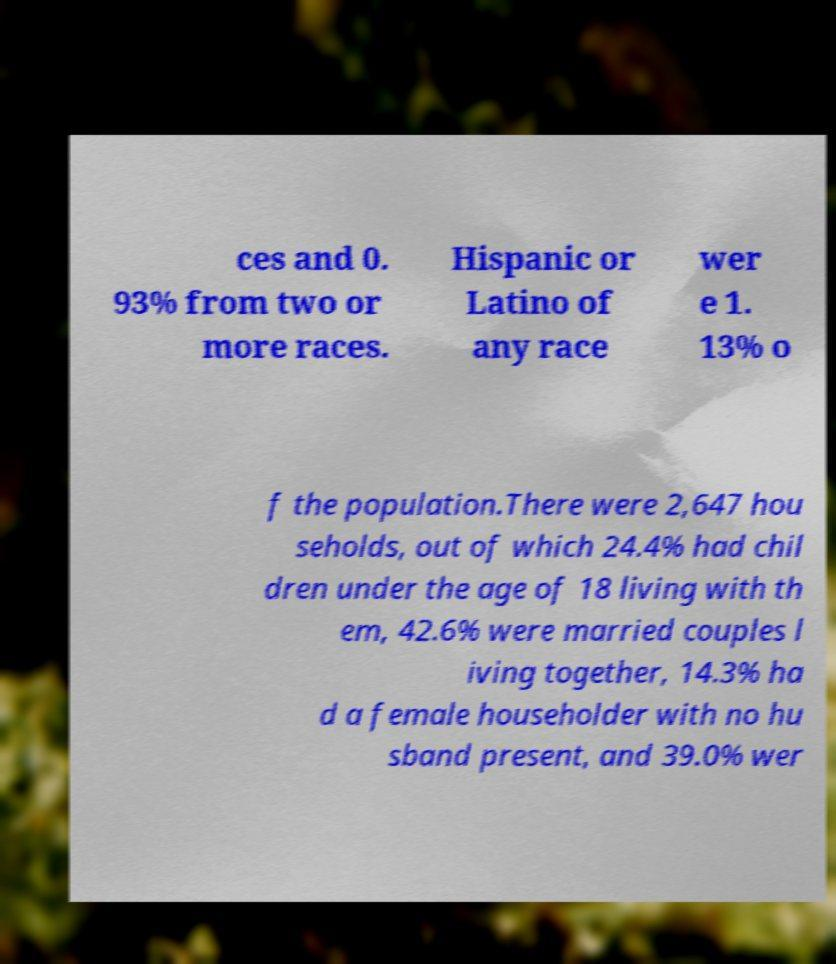What messages or text are displayed in this image? I need them in a readable, typed format. ces and 0. 93% from two or more races. Hispanic or Latino of any race wer e 1. 13% o f the population.There were 2,647 hou seholds, out of which 24.4% had chil dren under the age of 18 living with th em, 42.6% were married couples l iving together, 14.3% ha d a female householder with no hu sband present, and 39.0% wer 